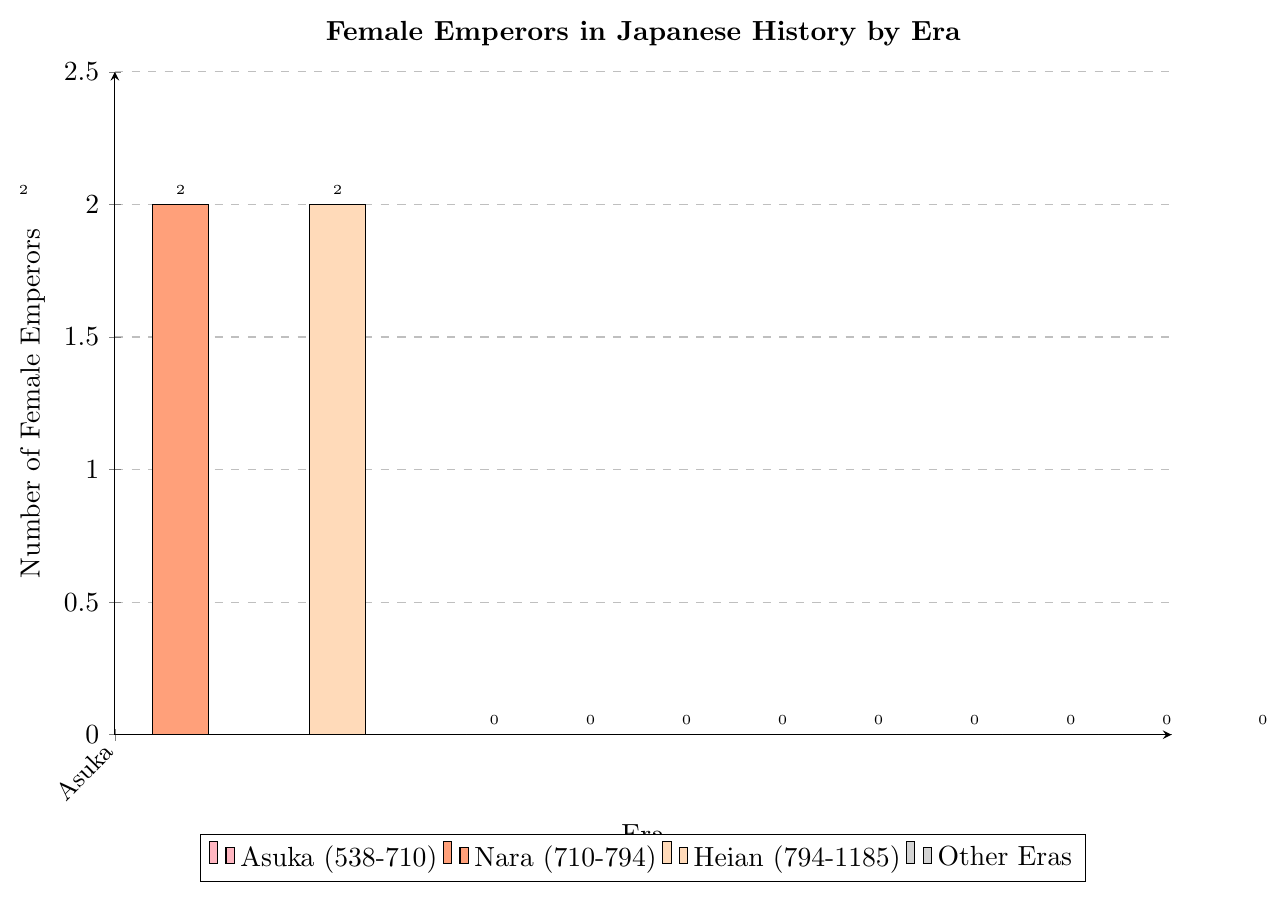What's the total number of female emperors across all eras? Add up the number of female emperors from each era: (2 + 2 + 2 + 0 + 0 + 0 + 0 + 0 + 0 + 0 + 0 + 0) = 6
Answer: 6 Which eras have female emperors? Identify the eras with bars higher than zero in the chart: Asuka, Nara, Heian
Answer: Asuka, Nara, Heian What's the difference in the number of female emperors between the Asuka era and the Kamakura era? Subtract the number of female emperors in the Kamakura era from the Asuka era: 2 - 0 = 2
Answer: 2 How many eras had no female emperors? Count the number of eras with bars showing zero female emperors: Kamakura, Muromachi, Azuchi-Momoyama, Edo, Meiji, Taisho, Showa, Heisei, Reiwa = 9 eras
Answer: 9 Which era had the same number of female emperors as the Heian era? Compare the bars with the bar from the Heian era showing 2 female emperors: Asuka, Nara
Answer: Asuka, Nara Sum the number of female emperors in the Nara and Heian eras. What do you get? Add the number of female emperors in Nara and Heian: 2 + 2 = 4
Answer: 4 What is the height of the bar representing the Edo era? Identify the height of the bar for the Edo era, which shows zero female emperors: The height is 0
Answer: 0 Looking at the colors, which era's bar is pink? The only pink-colored bar represents the Asuka era
Answer: Asuka Is there any era before the Edo period with no female emperors? Check periods before Edo (538-1868) using the chart’s data: Kamakura, Muromachi, Azuchi-Momoyama
Answer: Kamakura, Muromachi, Azuchi-Momoyama Between Nara and Heian eras, which one had more female emperors? Compare the heights of bars of Nara (2) and Heian (2) eras: Both are equal
Answer: Both are equal 